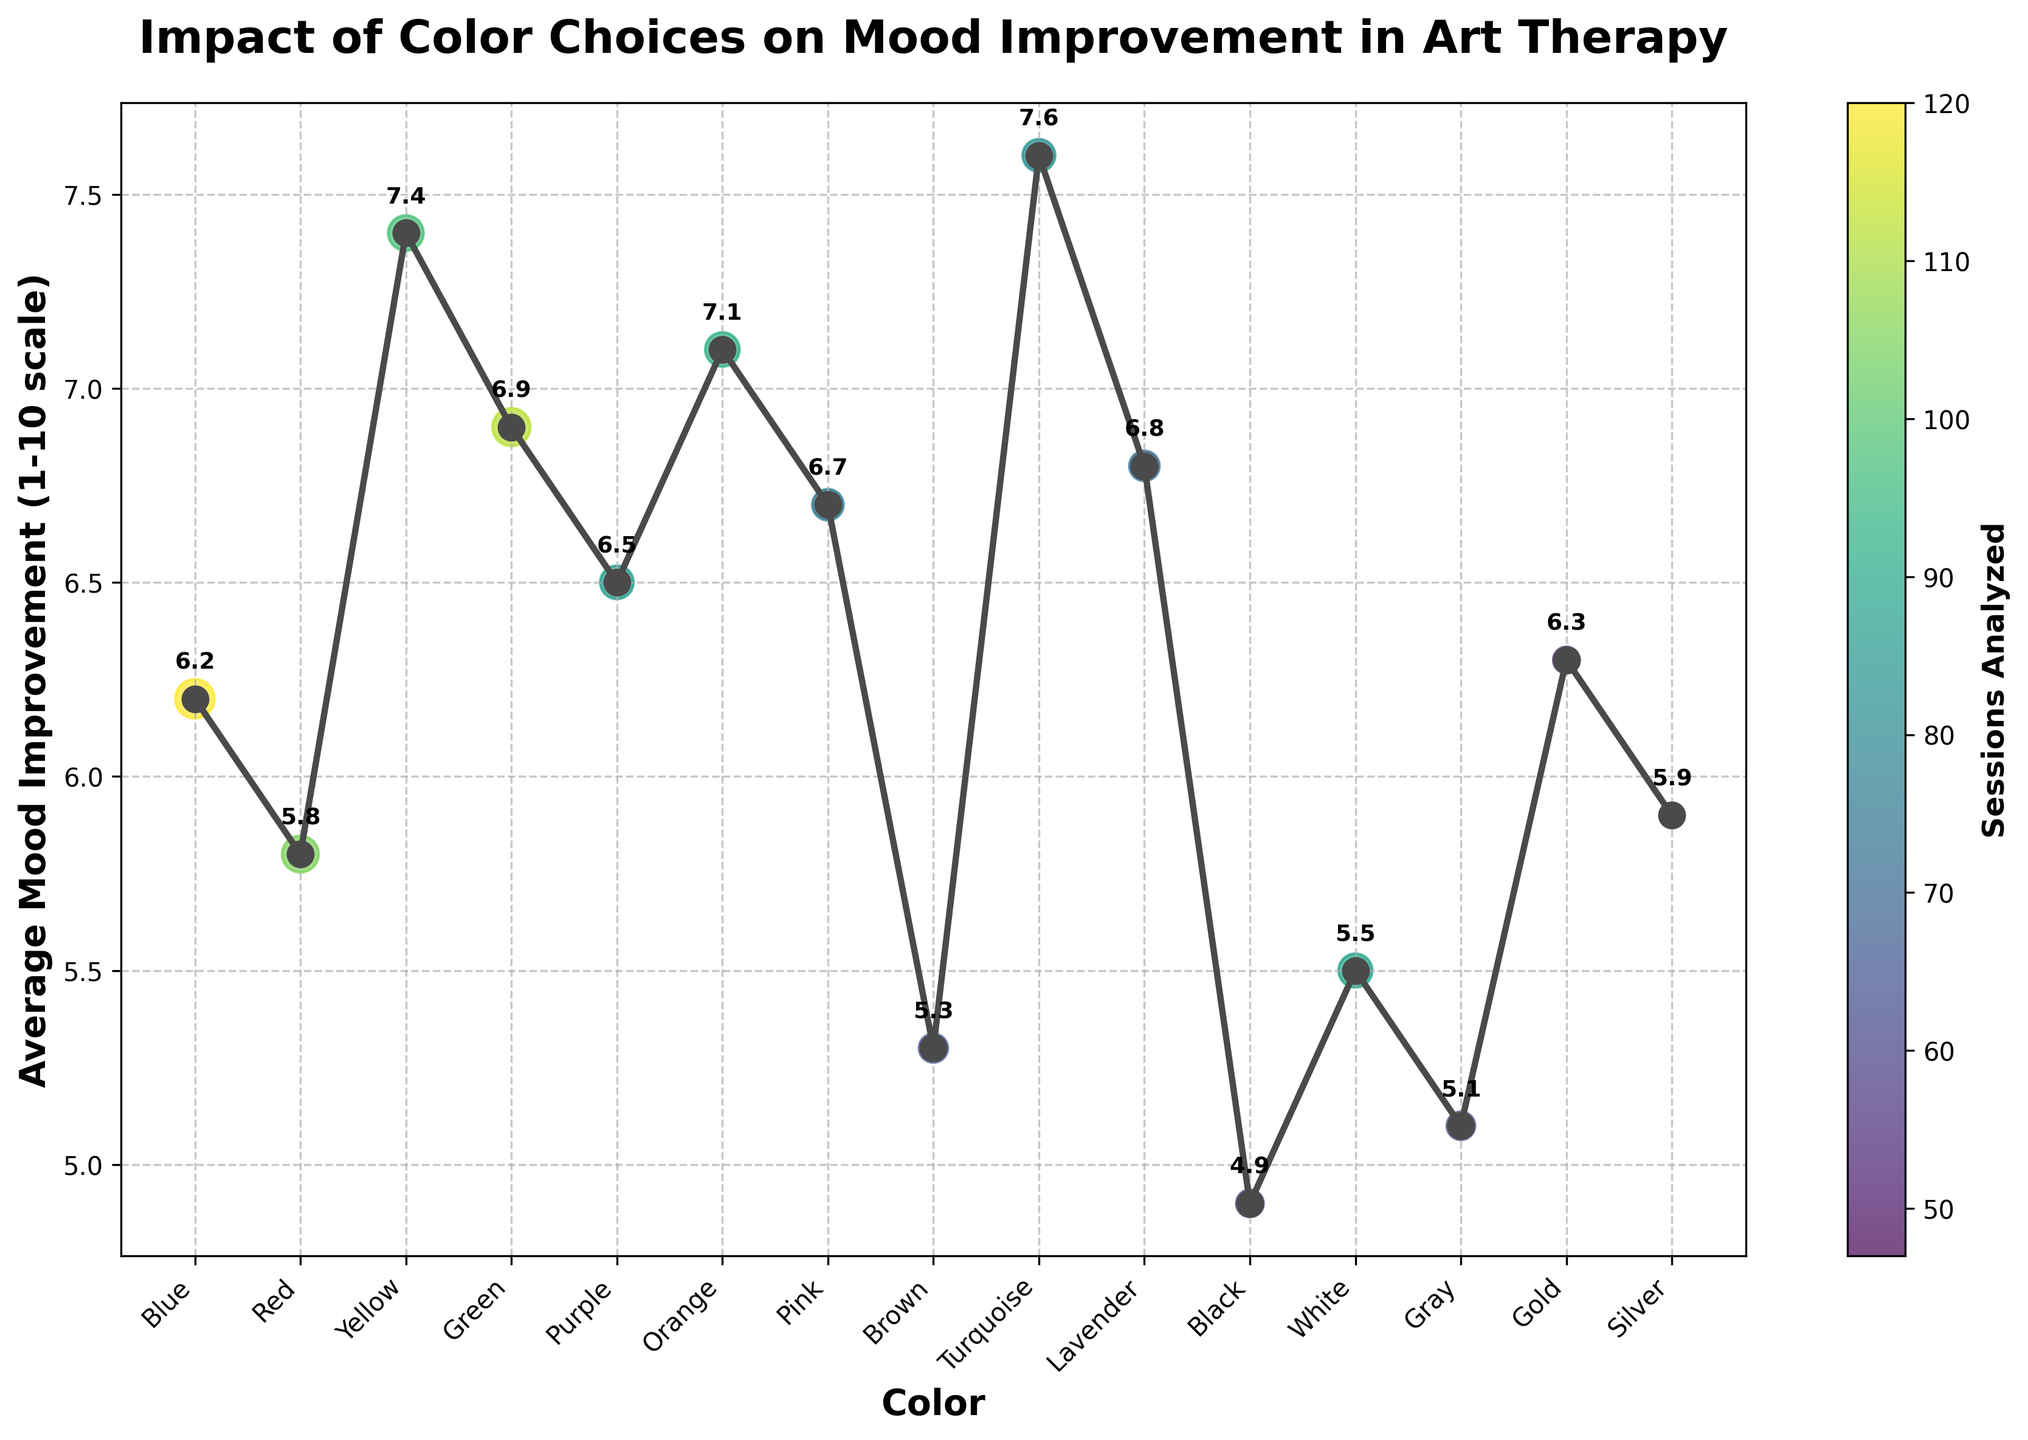What color has the highest average mood improvement in art therapy sessions? The chart shows the mood improvement scores along the y-axis. The highest point corresponds to Turquoise with a score of 7.6.
Answer: Turquoise Which color shows the lowest average mood improvement? By looking at the lowest point on the y-axis, Black has the lowest average mood improvement at 4.9.
Answer: Black How many sessions analyzed had an average mood improvement above 7? The chart shows mood improvement values and the colors associated with them. Yellow (7.4), Orange (7.1), and Turquoise (7.6) are the colors with scores above 7. Sum their sessions: Yellow (98) + Orange (92) + Turquoise (83) = 273.
Answer: 273 Compare the mood improvement scores between Blue and Green. Which one is higher and by how much? The chart shows Blue at 6.2 and Green at 6.9. Subtract Blue’s score from Green’s to find the difference: 6.9 - 6.2 = 0.7.
Answer: Green is higher by 0.7 Which color had more sessions analyzed, Purple or Brown? The chart indicates that Purple has 87 sessions analyzed, while Brown has 65. Since 87 > 65, Purple has more sessions analyzed.
Answer: Purple Find the difference in average mood improvement between the color with the highest and the lowest mood improvement. The highest mood improvement is Turquoise (7.6) and the lowest is Black (4.9). Subtract Black’s score from Turquoise’s: 7.6 - 4.9 = 2.7.
Answer: 2.7 What is the average mood improvement score for Red and Silver combined? The chart shows Red at 5.8 and Silver at 5.9. Add their scores and divide by 2: (5.8 + 5.9) / 2 = 5.85.
Answer: 5.85 Which color has the highest number of sessions analyzed, and what is its corresponding mood improvement score? The scatter plot shows the size of the markers proportionate to the sessions analyzed. Blue, with 120 sessions, has the highest number and its average mood improvement is 6.2.
Answer: Blue, 6.2 If we exclude the color with the highest mood improvement, what is the new highest mood improvement score? Excluding Turquoise (7.6), the next highest reported mood improvement score is Yellow at 7.4.
Answer: Yellow, 7.4 What is the sum of the average mood improvements for colors Blue, Green, and Yellow? The chart shows Blue (6.2), Green (6.9), and Yellow (7.4). Adding these scores gives 6.2 + 6.9 + 7.4 = 20.5.
Answer: 20.5 